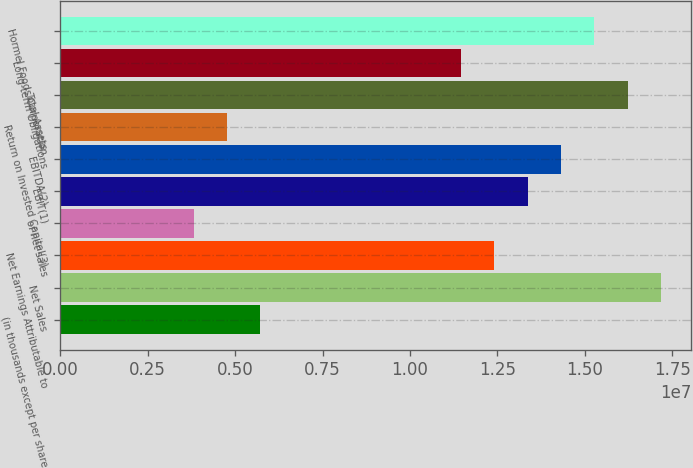<chart> <loc_0><loc_0><loc_500><loc_500><bar_chart><fcel>(in thousands except per share<fcel>Net Sales<fcel>Net Earnings Attributable to<fcel>of net sales<fcel>EBIT(1)<fcel>EBITDA(2)<fcel>Return on Invested Capital(3)<fcel>Total Assets<fcel>Long-term Obligations<fcel>Hormel Foods Corporation<nl><fcel>5.72742e+06<fcel>1.71823e+07<fcel>1.24094e+07<fcel>3.81828e+06<fcel>1.3364e+07<fcel>1.43185e+07<fcel>4.77285e+06<fcel>1.62277e+07<fcel>1.14548e+07<fcel>1.52731e+07<nl></chart> 